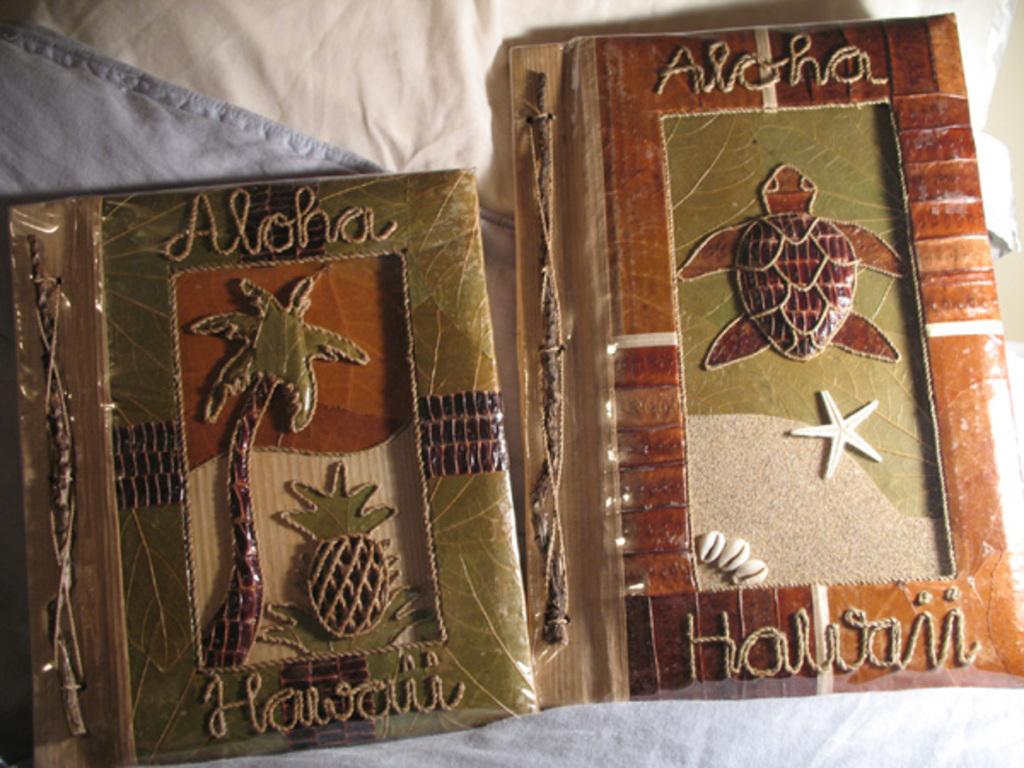What doe those decorations say?
Your response must be concise. Aloha hawaii. 